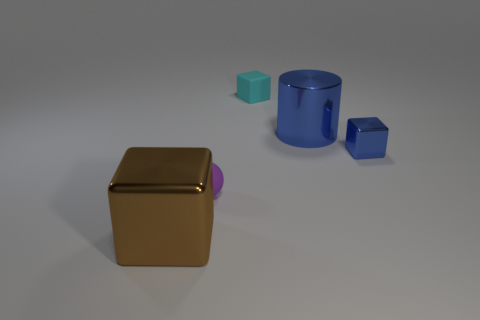Are there any cyan rubber cubes of the same size as the purple matte thing?
Provide a succinct answer. Yes. There is a purple thing that is the same size as the cyan rubber cube; what is it made of?
Offer a very short reply. Rubber. Do the purple ball and the block in front of the small purple matte thing have the same size?
Offer a very short reply. No. What is the tiny block on the right side of the small cyan thing made of?
Your answer should be very brief. Metal. Are there the same number of brown objects behind the brown object and rubber cubes?
Keep it short and to the point. No. Is the cyan block the same size as the brown thing?
Provide a short and direct response. No. Are there any rubber objects behind the tiny rubber thing that is behind the tiny block on the right side of the cyan rubber cube?
Keep it short and to the point. No. There is a cyan object that is the same shape as the brown shiny object; what is it made of?
Keep it short and to the point. Rubber. What number of small rubber cubes are right of the large object right of the brown metallic thing?
Give a very brief answer. 0. There is a object that is right of the large metal thing that is on the right side of the tiny thing on the left side of the cyan cube; how big is it?
Your response must be concise. Small. 